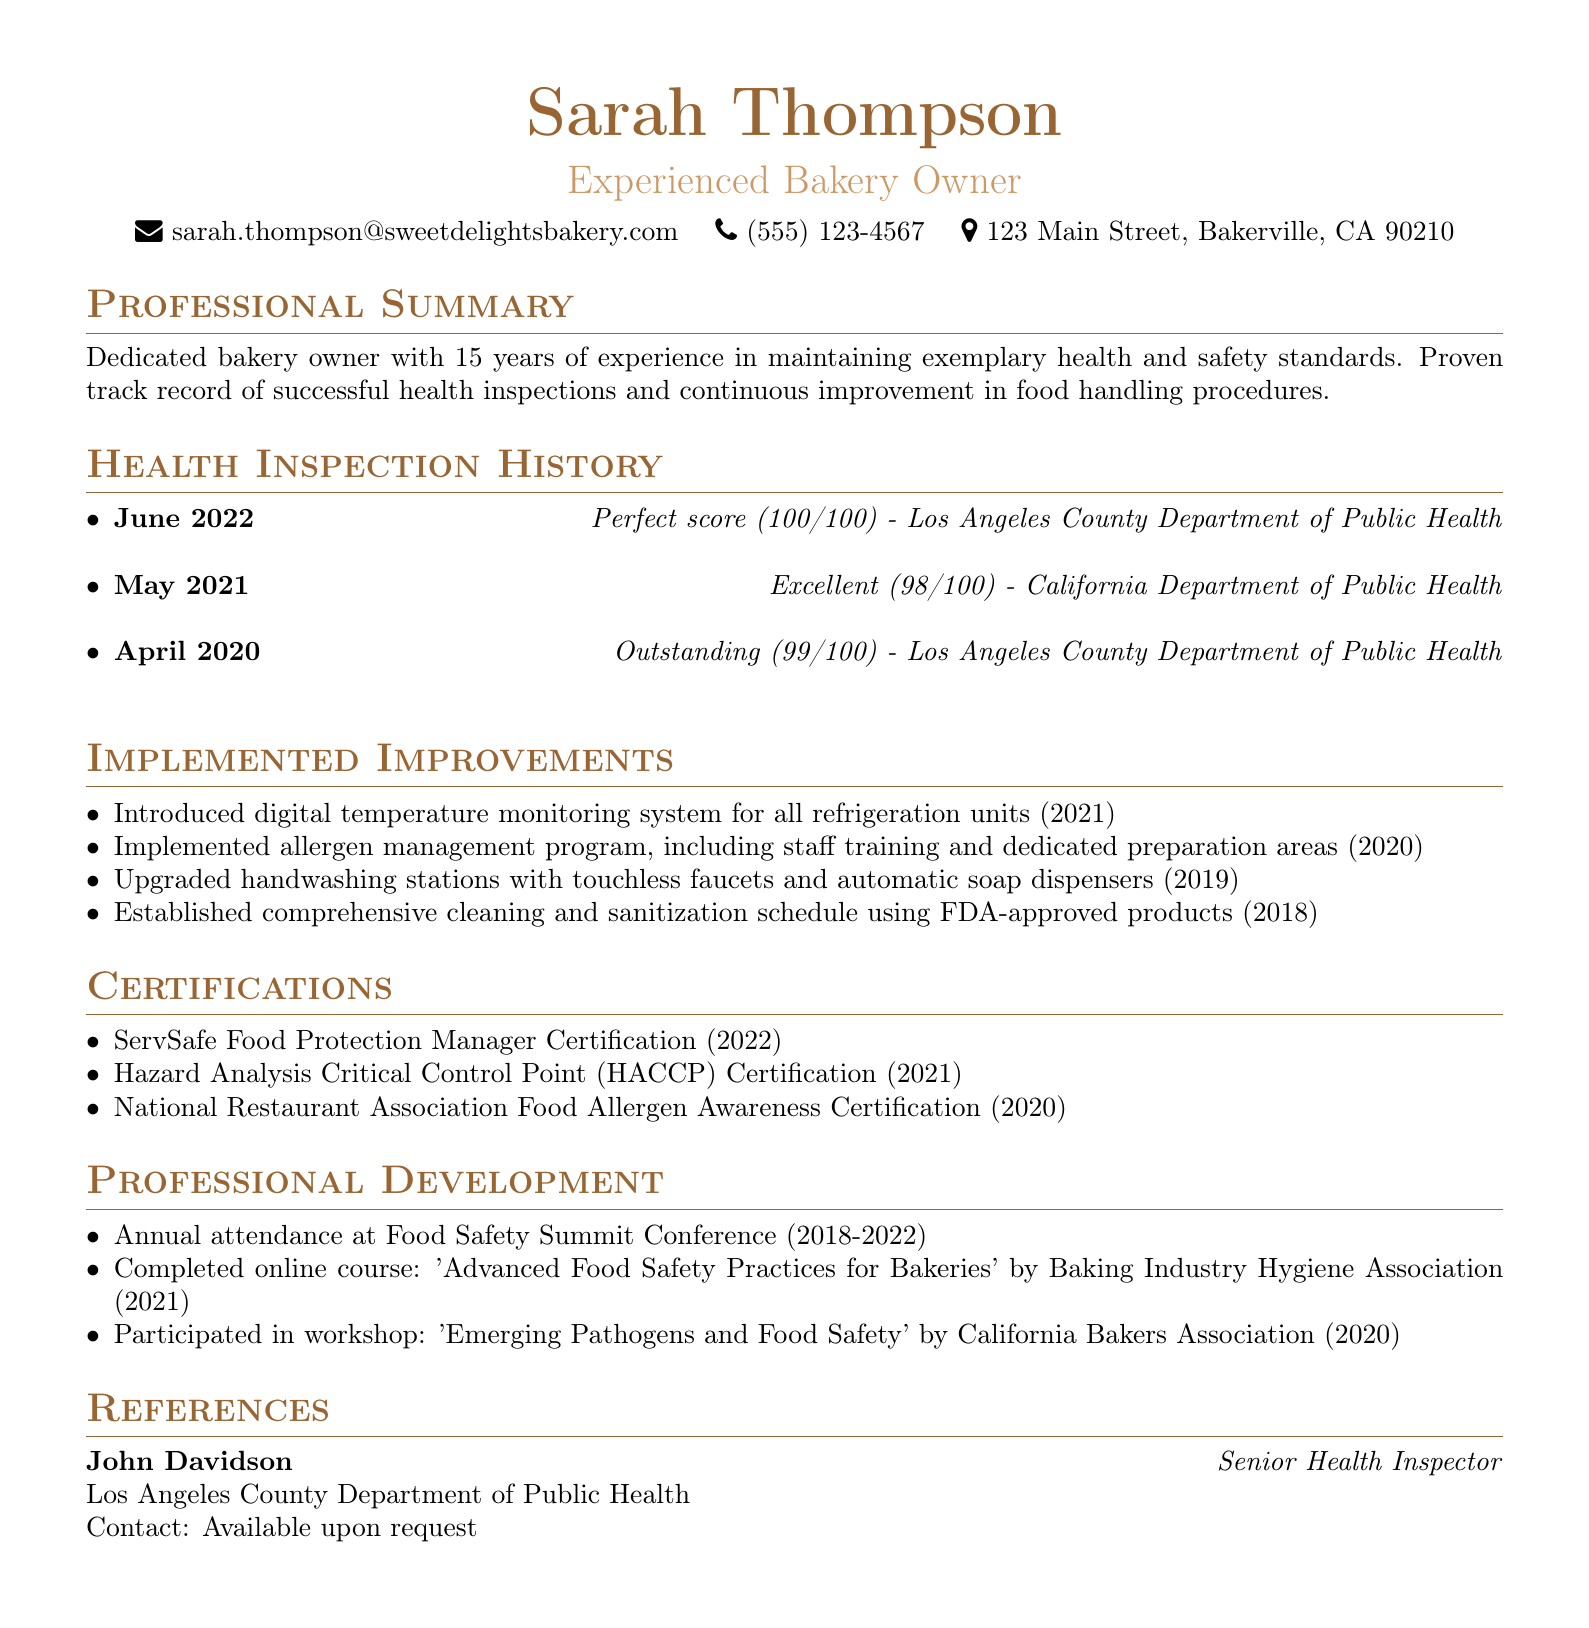what is the name of the bakery owner? The name is stated at the top of the document under personal information.
Answer: Sarah Thompson how many years of experience does the bakery owner have? The professional summary detail mentions the total years of experience.
Answer: 15 years what was the score on the June 2022 health inspection? The health inspection history indicates the score for this specific date.
Answer: Perfect score (100/100) which certification was obtained in 2022? The certifications section lists the certifications along with their years.
Answer: ServSafe Food Protection Manager Certification what improvement was implemented in 2021? The list under implemented improvements contains information about changes made each year.
Answer: Introduced digital temperature monitoring system for all refrigeration units who conducted the health inspection in May 2021? The health inspection history specifies the inspector for each inspection date.
Answer: California Department of Public Health how many professional development activities are listed? The professional development section includes all activities participated in by the bakery owner.
Answer: 3 what is the title of the reference? The references section provides the title of the listed reference.
Answer: Senior Health Inspector 